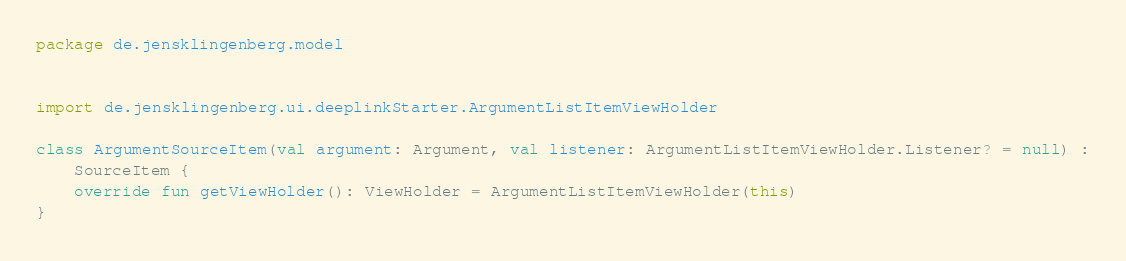Convert code to text. <code><loc_0><loc_0><loc_500><loc_500><_Kotlin_>package de.jensklingenberg.model


import de.jensklingenberg.ui.deeplinkStarter.ArgumentListItemViewHolder

class ArgumentSourceItem(val argument: Argument, val listener: ArgumentListItemViewHolder.Listener? = null) :
    SourceItem {
    override fun getViewHolder(): ViewHolder = ArgumentListItemViewHolder(this)
}</code> 